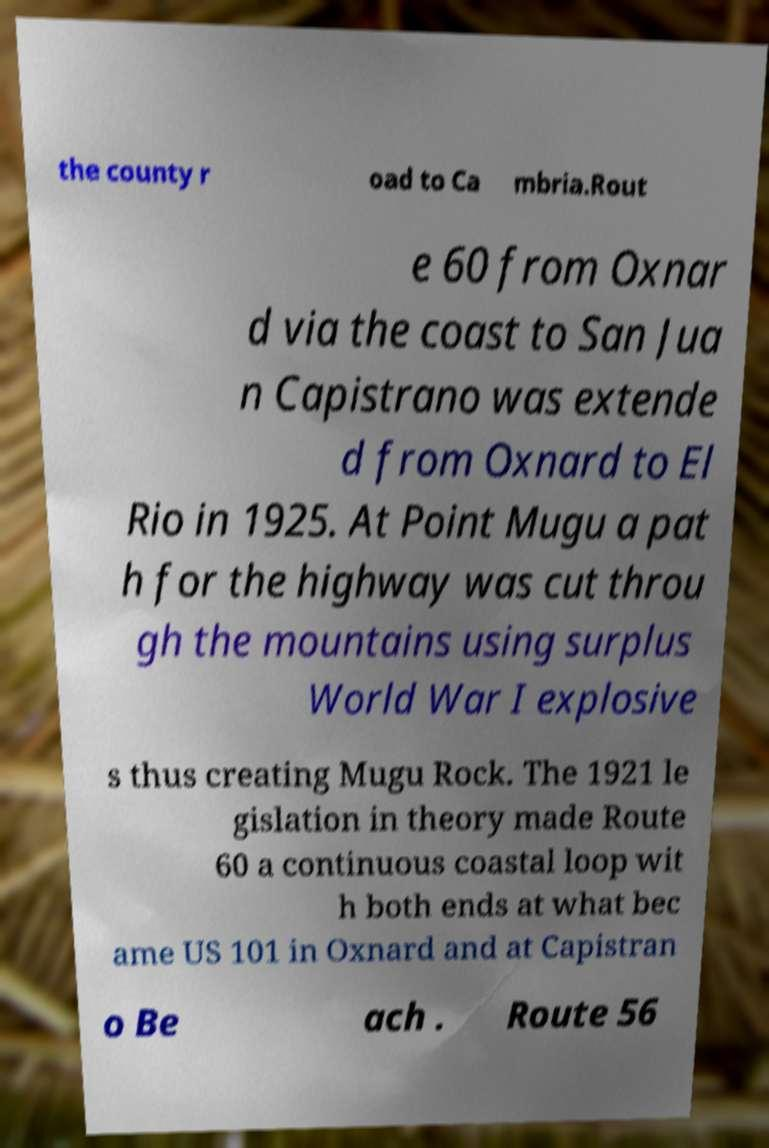Please identify and transcribe the text found in this image. the county r oad to Ca mbria.Rout e 60 from Oxnar d via the coast to San Jua n Capistrano was extende d from Oxnard to El Rio in 1925. At Point Mugu a pat h for the highway was cut throu gh the mountains using surplus World War I explosive s thus creating Mugu Rock. The 1921 le gislation in theory made Route 60 a continuous coastal loop wit h both ends at what bec ame US 101 in Oxnard and at Capistran o Be ach . Route 56 